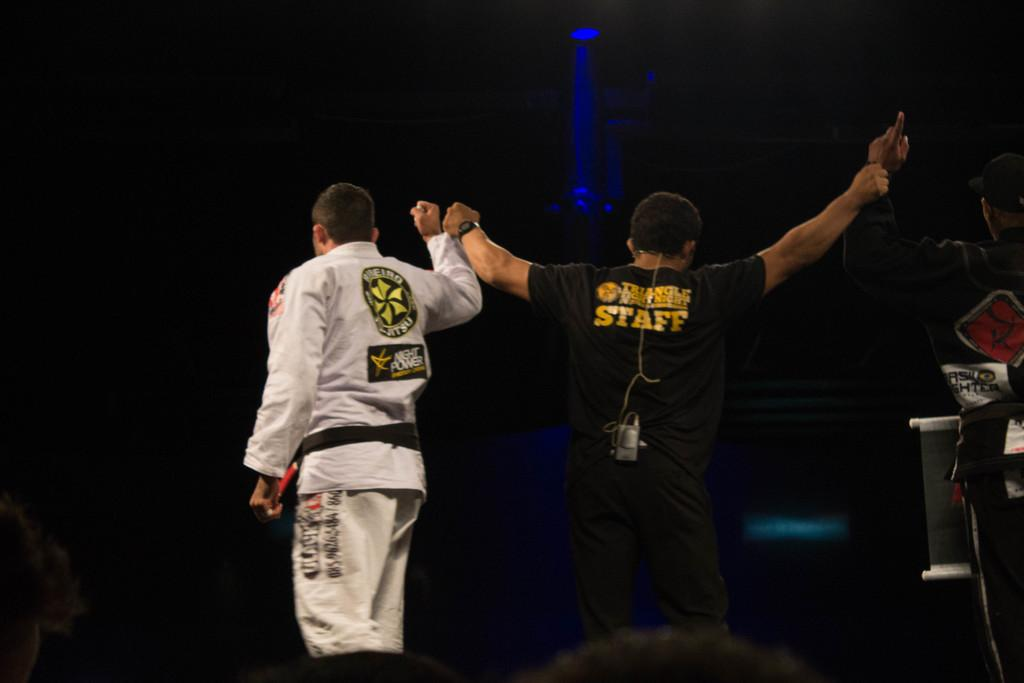Provide a one-sentence caption for the provided image. A member of the Triangle Fight Night staff is standing nect to one of the fighters. 